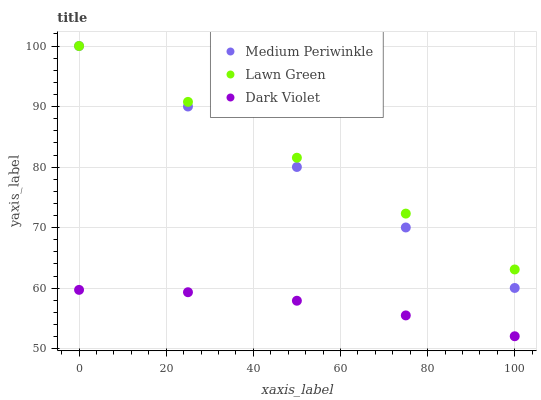Does Dark Violet have the minimum area under the curve?
Answer yes or no. Yes. Does Lawn Green have the maximum area under the curve?
Answer yes or no. Yes. Does Medium Periwinkle have the minimum area under the curve?
Answer yes or no. No. Does Medium Periwinkle have the maximum area under the curve?
Answer yes or no. No. Is Lawn Green the smoothest?
Answer yes or no. Yes. Is Dark Violet the roughest?
Answer yes or no. Yes. Is Dark Violet the smoothest?
Answer yes or no. No. Is Medium Periwinkle the roughest?
Answer yes or no. No. Does Dark Violet have the lowest value?
Answer yes or no. Yes. Does Medium Periwinkle have the lowest value?
Answer yes or no. No. Does Medium Periwinkle have the highest value?
Answer yes or no. Yes. Does Dark Violet have the highest value?
Answer yes or no. No. Is Dark Violet less than Medium Periwinkle?
Answer yes or no. Yes. Is Medium Periwinkle greater than Dark Violet?
Answer yes or no. Yes. Does Medium Periwinkle intersect Lawn Green?
Answer yes or no. Yes. Is Medium Periwinkle less than Lawn Green?
Answer yes or no. No. Is Medium Periwinkle greater than Lawn Green?
Answer yes or no. No. Does Dark Violet intersect Medium Periwinkle?
Answer yes or no. No. 